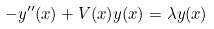Convert formula to latex. <formula><loc_0><loc_0><loc_500><loc_500>- y ^ { \prime \prime } ( x ) + V ( x ) y ( x ) = \lambda y ( x )</formula> 